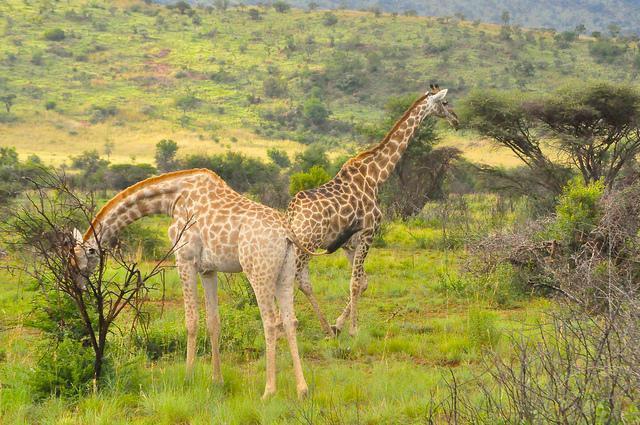How many giraffes can you see?
Give a very brief answer. 2. 